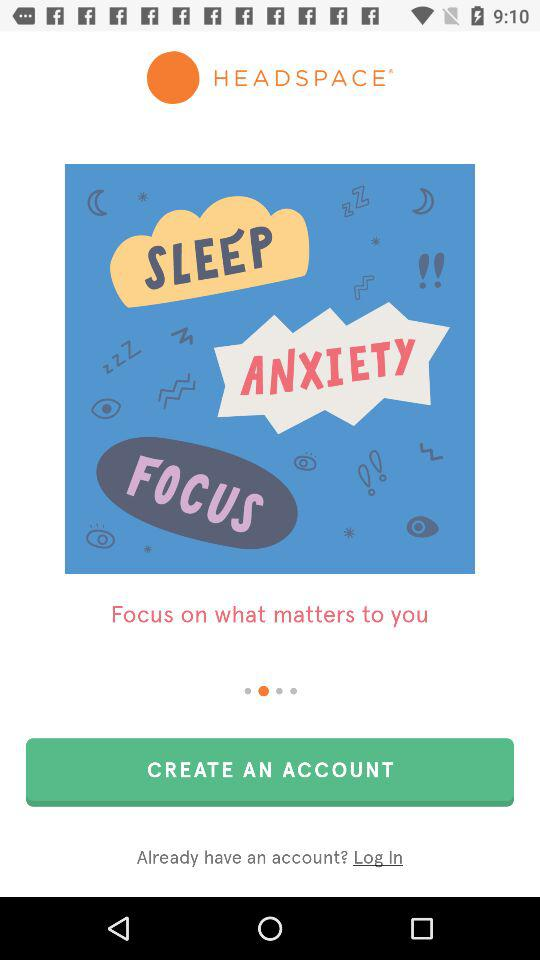What is the application name? The application name is "HEADSPACE". 